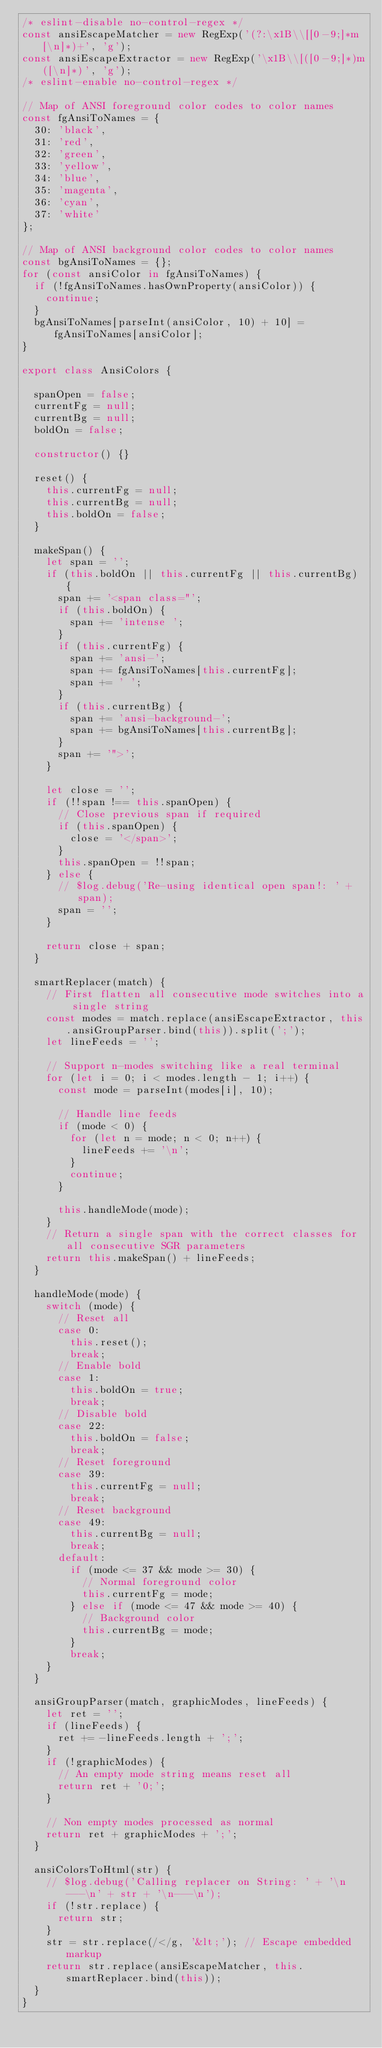Convert code to text. <code><loc_0><loc_0><loc_500><loc_500><_TypeScript_>/* eslint-disable no-control-regex */
const ansiEscapeMatcher = new RegExp('(?:\x1B\\[[0-9;]*m[\n]*)+', 'g');
const ansiEscapeExtractor = new RegExp('\x1B\\[([0-9;]*)m([\n]*)', 'g');
/* eslint-enable no-control-regex */

// Map of ANSI foreground color codes to color names
const fgAnsiToNames = {
  30: 'black',
  31: 'red',
  32: 'green',
  33: 'yellow',
  34: 'blue',
  35: 'magenta',
  36: 'cyan',
  37: 'white'
};

// Map of ANSI background color codes to color names
const bgAnsiToNames = {};
for (const ansiColor in fgAnsiToNames) {
  if (!fgAnsiToNames.hasOwnProperty(ansiColor)) {
    continue;
  }
  bgAnsiToNames[parseInt(ansiColor, 10) + 10] = fgAnsiToNames[ansiColor];
}

export class AnsiColors {

  spanOpen = false;
  currentFg = null;
  currentBg = null;
  boldOn = false;

  constructor() {}

  reset() {
    this.currentFg = null;
    this.currentBg = null;
    this.boldOn = false;
  }

  makeSpan() {
    let span = '';
    if (this.boldOn || this.currentFg || this.currentBg) {
      span += '<span class="';
      if (this.boldOn) {
        span += 'intense ';
      }
      if (this.currentFg) {
        span += 'ansi-';
        span += fgAnsiToNames[this.currentFg];
        span += ' ';
      }
      if (this.currentBg) {
        span += 'ansi-background-';
        span += bgAnsiToNames[this.currentBg];
      }
      span += '">';
    }

    let close = '';
    if (!!span !== this.spanOpen) {
      // Close previous span if required
      if (this.spanOpen) {
        close = '</span>';
      }
      this.spanOpen = !!span;
    } else {
      // $log.debug('Re-using identical open span!: ' + span);
      span = '';
    }

    return close + span;
  }

  smartReplacer(match) {
    // First flatten all consecutive mode switches into a single string
    const modes = match.replace(ansiEscapeExtractor, this.ansiGroupParser.bind(this)).split(';');
    let lineFeeds = '';

    // Support n-modes switching like a real terminal
    for (let i = 0; i < modes.length - 1; i++) {
      const mode = parseInt(modes[i], 10);

      // Handle line feeds
      if (mode < 0) {
        for (let n = mode; n < 0; n++) {
          lineFeeds += '\n';
        }
        continue;
      }

      this.handleMode(mode);
    }
    // Return a single span with the correct classes for all consecutive SGR parameters
    return this.makeSpan() + lineFeeds;
  }

  handleMode(mode) {
    switch (mode) {
      // Reset all
      case 0:
        this.reset();
        break;
      // Enable bold
      case 1:
        this.boldOn = true;
        break;
      // Disable bold
      case 22:
        this.boldOn = false;
        break;
      // Reset foreground
      case 39:
        this.currentFg = null;
        break;
      // Reset background
      case 49:
        this.currentBg = null;
        break;
      default:
        if (mode <= 37 && mode >= 30) {
          // Normal foreground color
          this.currentFg = mode;
        } else if (mode <= 47 && mode >= 40) {
          // Background color
          this.currentBg = mode;
        }
        break;
    }
  }

  ansiGroupParser(match, graphicModes, lineFeeds) {
    let ret = '';
    if (lineFeeds) {
      ret += -lineFeeds.length + ';';
    }
    if (!graphicModes) {
      // An empty mode string means reset all
      return ret + '0;';
    }

    // Non empty modes processed as normal
    return ret + graphicModes + ';';
  }

  ansiColorsToHtml(str) {
    // $log.debug('Calling replacer on String: ' + '\n---\n' + str + '\n---\n');
    if (!str.replace) {
      return str;
    }
    str = str.replace(/</g, '&lt;'); // Escape embedded markup
    return str.replace(ansiEscapeMatcher, this.smartReplacer.bind(this));
  }
}
</code> 